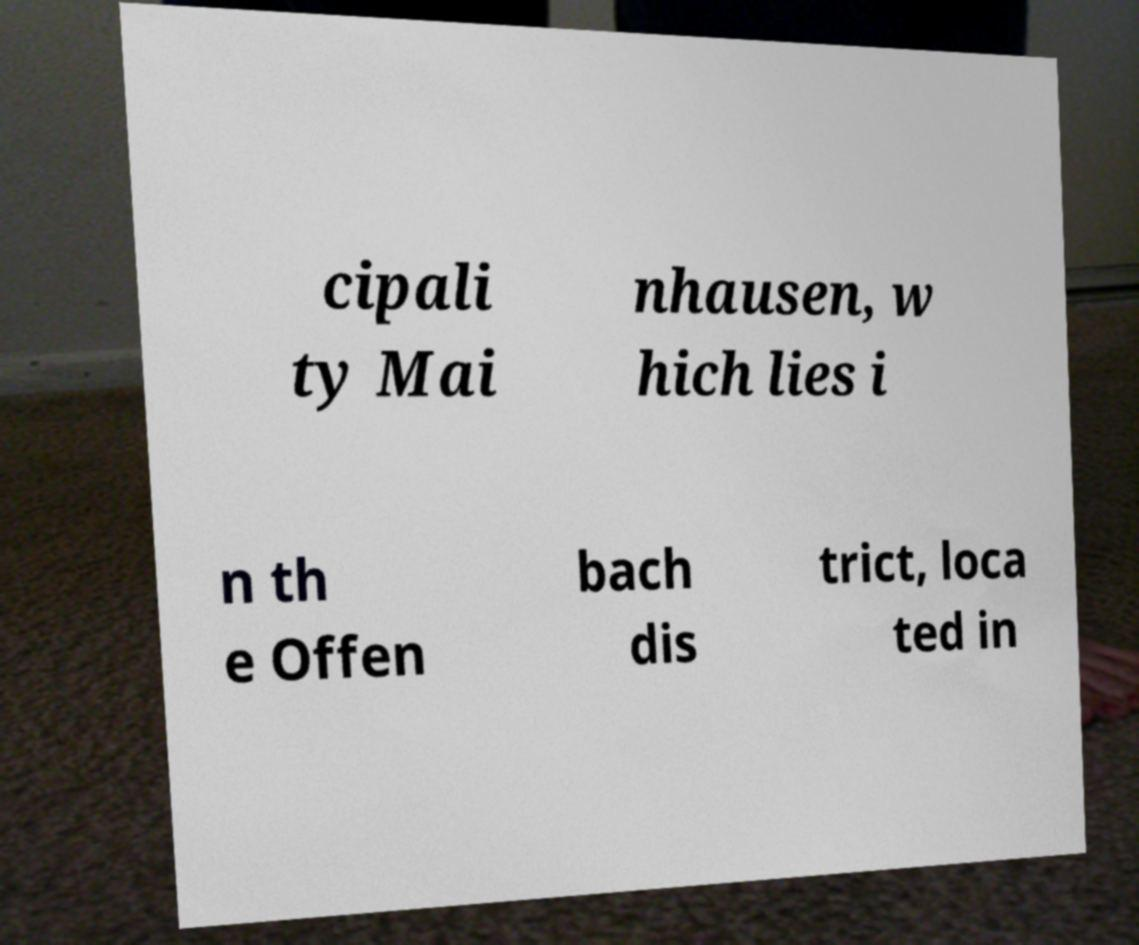Could you assist in decoding the text presented in this image and type it out clearly? cipali ty Mai nhausen, w hich lies i n th e Offen bach dis trict, loca ted in 